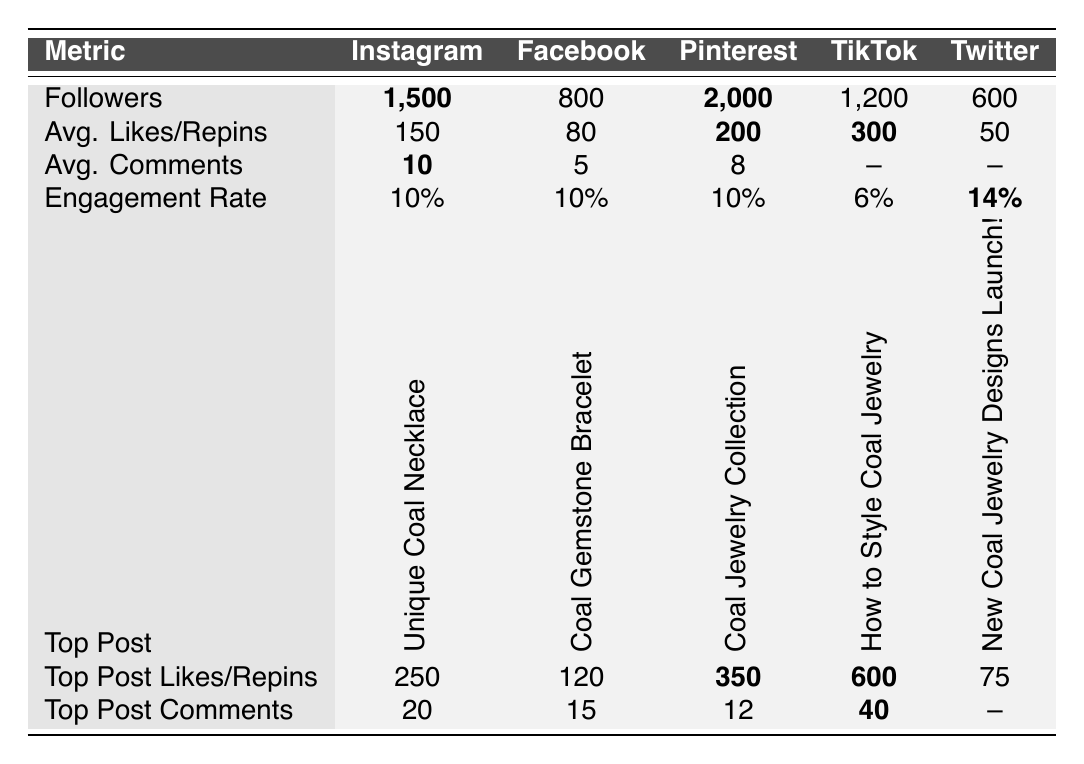What is the engagement rate on Twitter? The table shows that the engagement rate for Twitter is listed under the Engagement Rate column, where it states 14%.
Answer: 14% Which platform has the highest average likes for posts? By comparing the Average Likes/Repins column, TikTok has the highest average likes with 300.
Answer: 300 Is the engagement rate consistent across all platforms? According to the table, Instagram, Facebook, and Pinterest have the same engagement rate of 10%, while TikTok has a lower engagement rate of 6%, and Twitter has a higher engagement rate of 14%, indicating inconsistency.
Answer: No What is the total number of followers across all platforms? Adding the followers from each platform: 1500 (Instagram) + 800 (Facebook) + 2000 (Pinterest) + 1200 (TikTok) + 600 (Twitter) totals to 5100 followers.
Answer: 5100 Which post on Pinterest had the most repins? The Top Pin in Pinterest indicates that "Coal Jewelry Collection" had 350 repins, making it the most repinned post on that platform.
Answer: 350 Which platform had the most comments on their top post? Looking at the Top Post Comments, TikTok had the highest number of comments on its top video, with 40 comments.
Answer: 40 What is the difference in average views between TikTok and Instagram? The Average Views for TikTok is 5000 and Instagram does not have a value listed for views, only likes, indicating a lack of comparability. Thus, the difference cannot be computed.
Answer: Not applicable Which platform is likely to have more content interaction based on engagement rate? Since Twitter has the highest engagement rate at 14%, it's expected to have more interaction compared to the others which are lower at 10% and 6%.
Answer: Twitter How does the average comments on Instagram compare to Facebook? Instagram has an average of 10 comments while Facebook has 5 comments, which means Instagram has 5 more average comments than Facebook.
Answer: 5 more Which platform's top post received more likes than its average likes? Upon checking, the top post on Instagram received 250 likes, which is significantly higher than its average of 150 likes. Thus, it did receive more likes.
Answer: Yes 